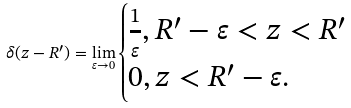<formula> <loc_0><loc_0><loc_500><loc_500>\delta ( z - R ^ { \prime } ) = \lim _ { \varepsilon \rightarrow 0 } \begin{cases} \frac { 1 } { \varepsilon } , R ^ { \prime } - \varepsilon < z < R ^ { \prime } \\ 0 , z < R ^ { \prime } - \varepsilon . \end{cases}</formula> 